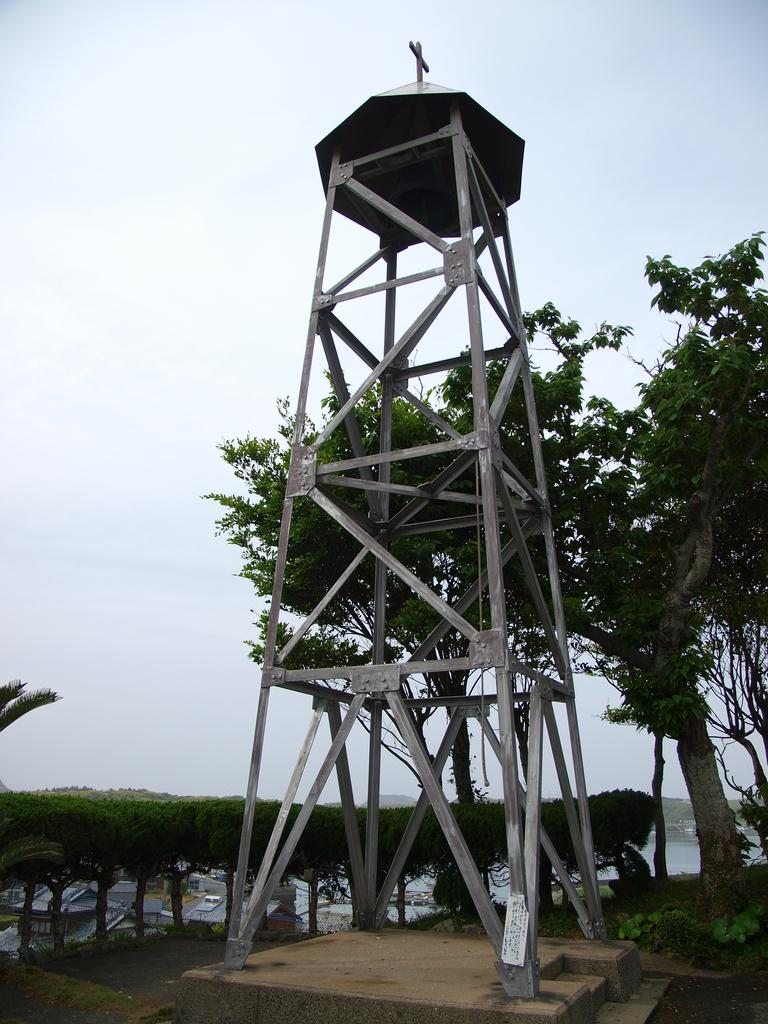What type of structure is present in the image? There is a metal tower in the image. What is the metal tower resting on? The metal tower is placed on a wooden surface. What can be seen in the background of the image? There are trees visible in the image. What is visible above the metal tower and trees? The sky is visible in the image. What type of scent can be detected coming from the metal tower in the image? There is no indication of a scent in the image, as it features a metal tower on a wooden surface with trees and the sky visible in the background. 